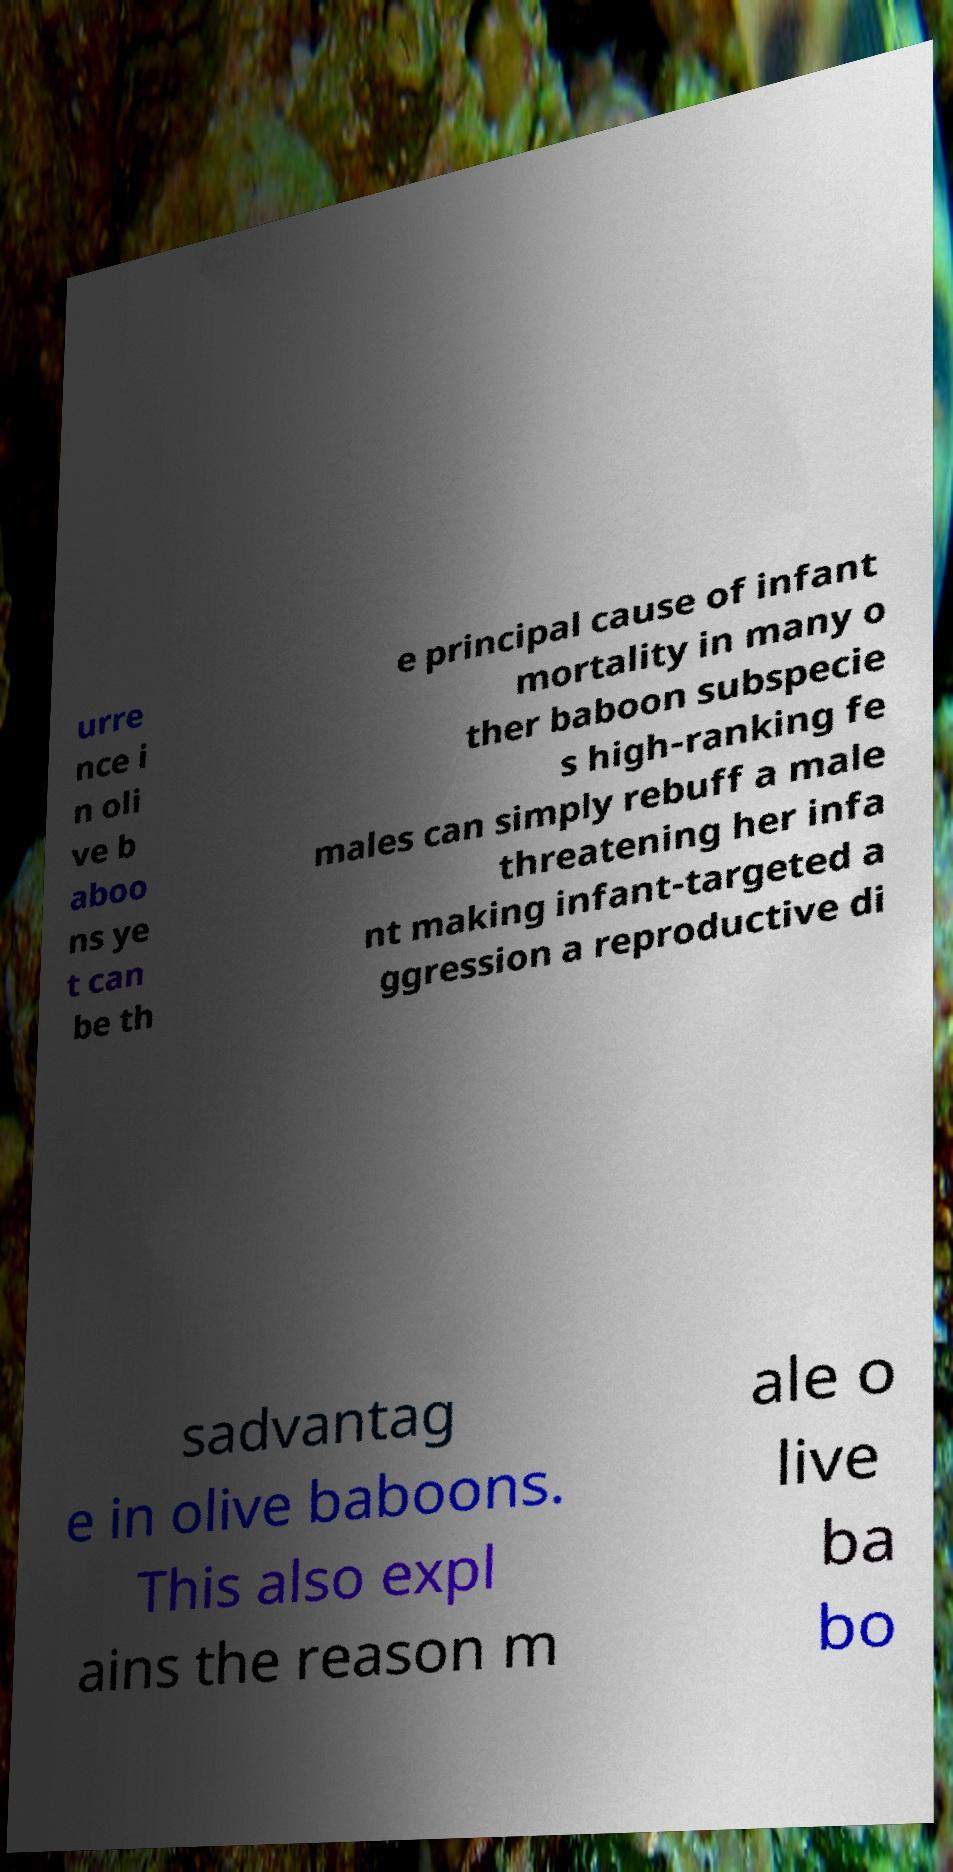Could you extract and type out the text from this image? urre nce i n oli ve b aboo ns ye t can be th e principal cause of infant mortality in many o ther baboon subspecie s high-ranking fe males can simply rebuff a male threatening her infa nt making infant-targeted a ggression a reproductive di sadvantag e in olive baboons. This also expl ains the reason m ale o live ba bo 